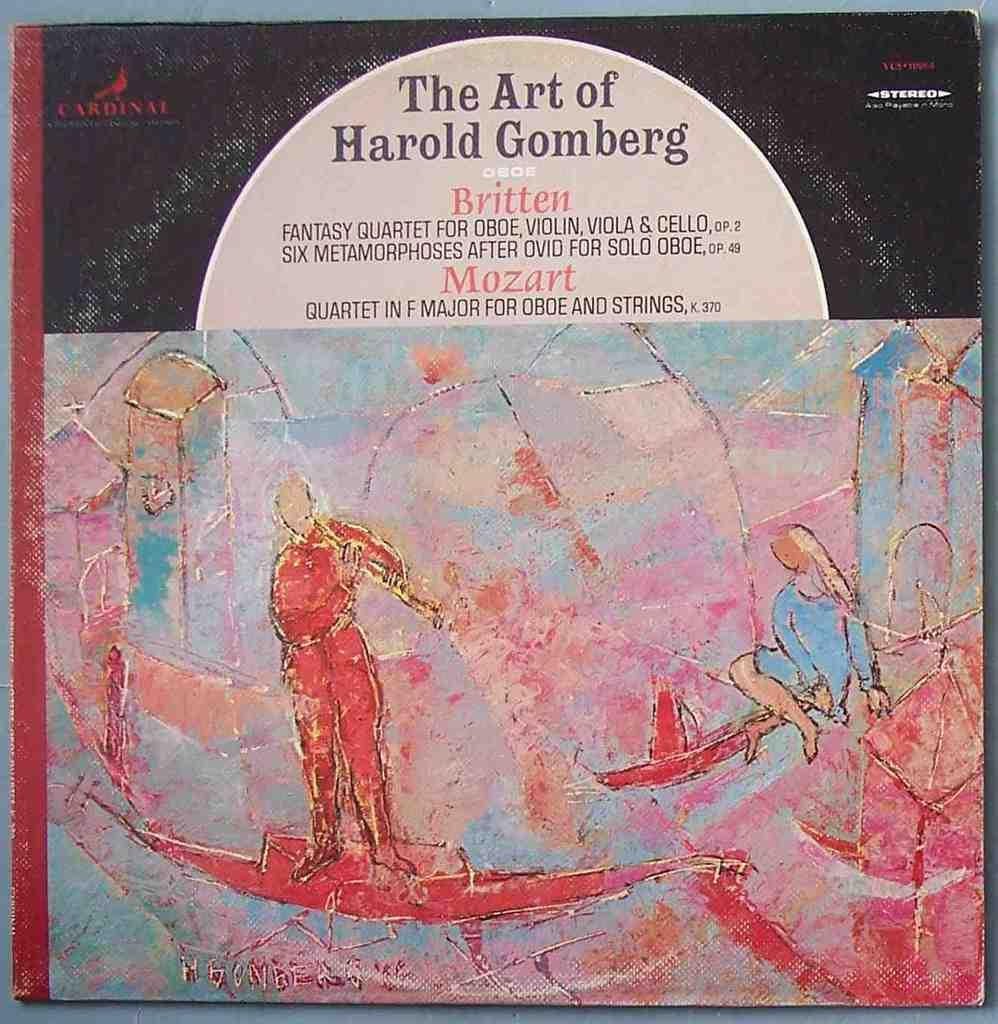<image>
Summarize the visual content of the image. A recording which is called The Art of Harold Gomberg. 